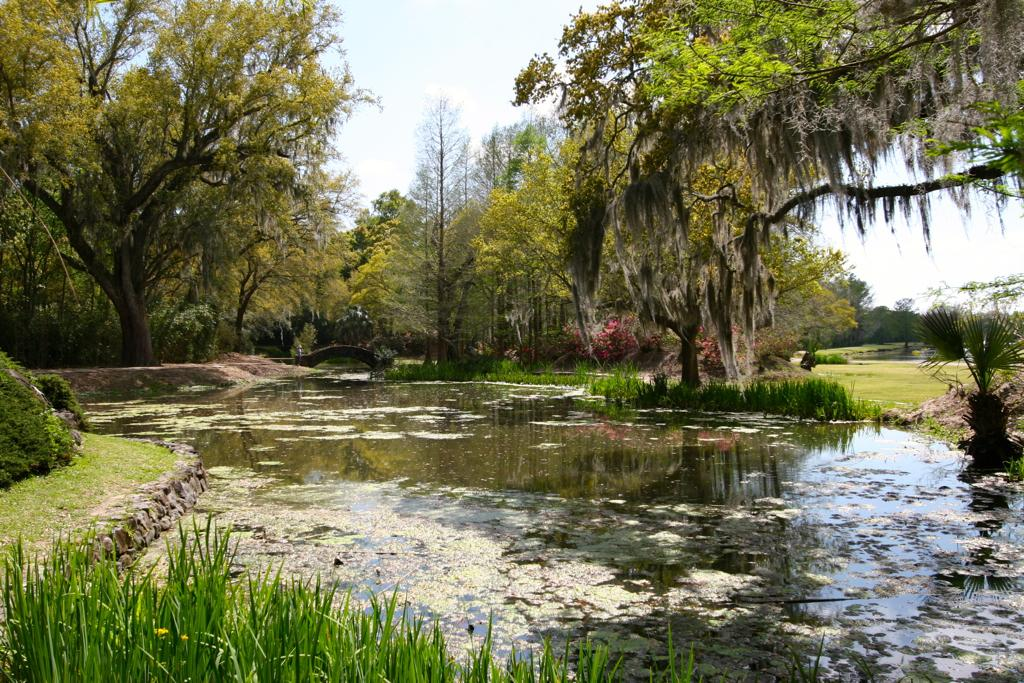What is the primary element in the image? There is water in the image. What can be seen floating in the water? Algae are present in the water. What type of vegetation is visible in the image? There are plants and grass visible in the image. What can be seen in the background of the image? There are trees and the sky visible in the background of the image. What type of ticket can be seen in the image? There is no ticket present in the image. How does the anger of the plants affect the water in the image? The plants in the image do not display anger, and there is no indication that their emotions would affect the water. 